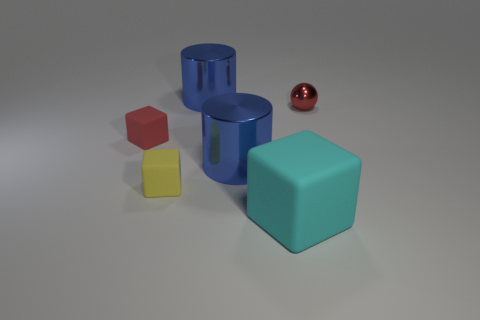The cyan matte block has what size?
Provide a succinct answer. Large. Is there a large cyan matte thing that has the same shape as the red rubber object?
Your answer should be compact. Yes. Are there an equal number of tiny red rubber blocks that are right of the small ball and blue cylinders?
Make the answer very short. No. Is the size of the cyan thing the same as the thing to the right of the big cyan matte cube?
Make the answer very short. No. What number of large blocks are made of the same material as the tiny red sphere?
Offer a very short reply. 0. Is the size of the cyan thing the same as the red metal sphere?
Your response must be concise. No. Is there anything else that has the same color as the small metal sphere?
Offer a very short reply. Yes. What shape is the matte thing that is left of the big cyan block and in front of the tiny red cube?
Your answer should be very brief. Cube. There is a blue metallic cylinder that is in front of the red block; what size is it?
Your answer should be very brief. Large. There is a blue cylinder that is behind the red thing in front of the red ball; what number of large blue things are left of it?
Offer a terse response. 0. 